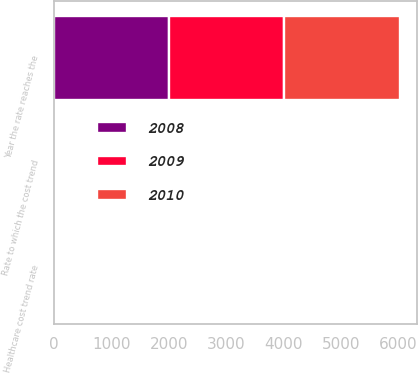Convert chart to OTSL. <chart><loc_0><loc_0><loc_500><loc_500><stacked_bar_chart><ecel><fcel>Healthcare cost trend rate<fcel>Rate to which the cost trend<fcel>Year the rate reaches the<nl><fcel>2010<fcel>3<fcel>3<fcel>2010<nl><fcel>2008<fcel>3<fcel>3<fcel>2009<nl><fcel>2009<fcel>3<fcel>3<fcel>2008<nl></chart> 